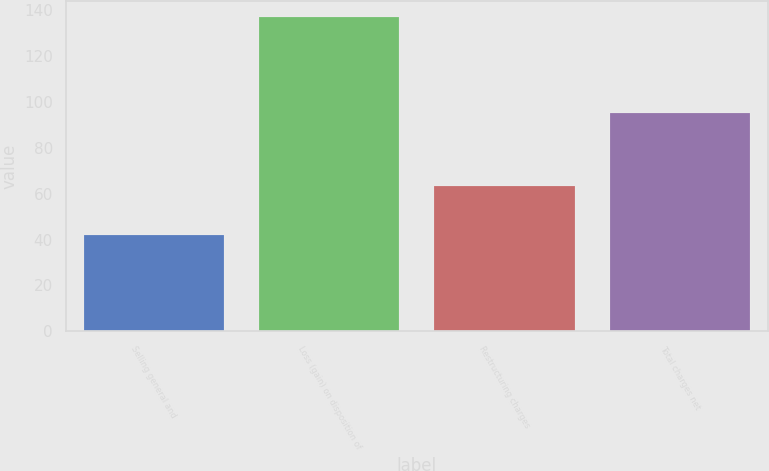Convert chart. <chart><loc_0><loc_0><loc_500><loc_500><bar_chart><fcel>Selling general and<fcel>Loss (gain) on disposition of<fcel>Restructuring charges<fcel>Total charges net<nl><fcel>41.8<fcel>137<fcel>63.2<fcel>95.3<nl></chart> 